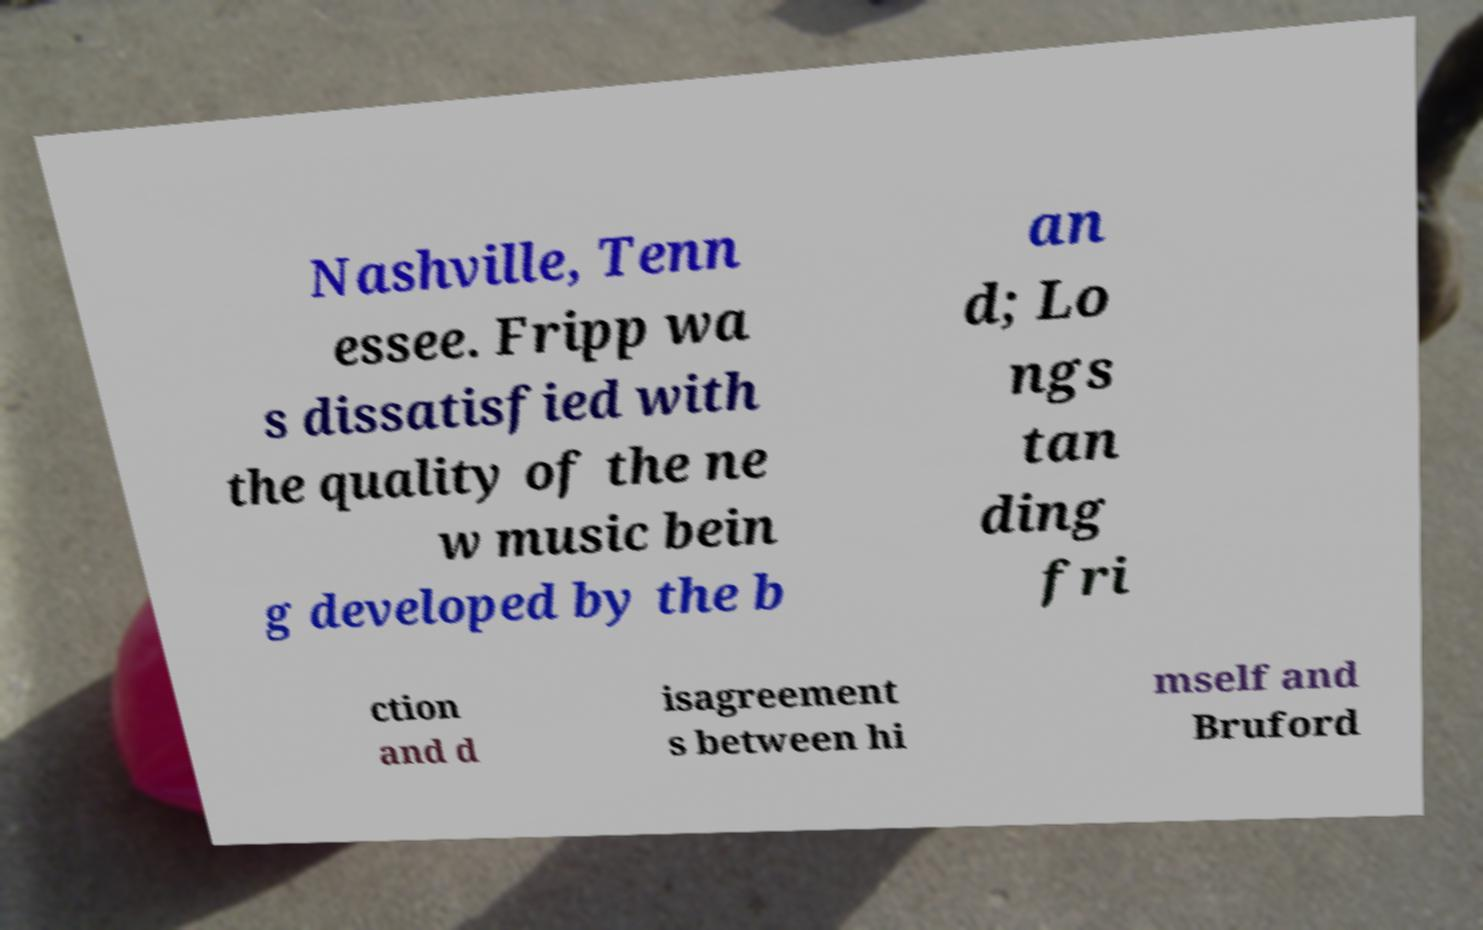There's text embedded in this image that I need extracted. Can you transcribe it verbatim? Nashville, Tenn essee. Fripp wa s dissatisfied with the quality of the ne w music bein g developed by the b an d; Lo ngs tan ding fri ction and d isagreement s between hi mself and Bruford 